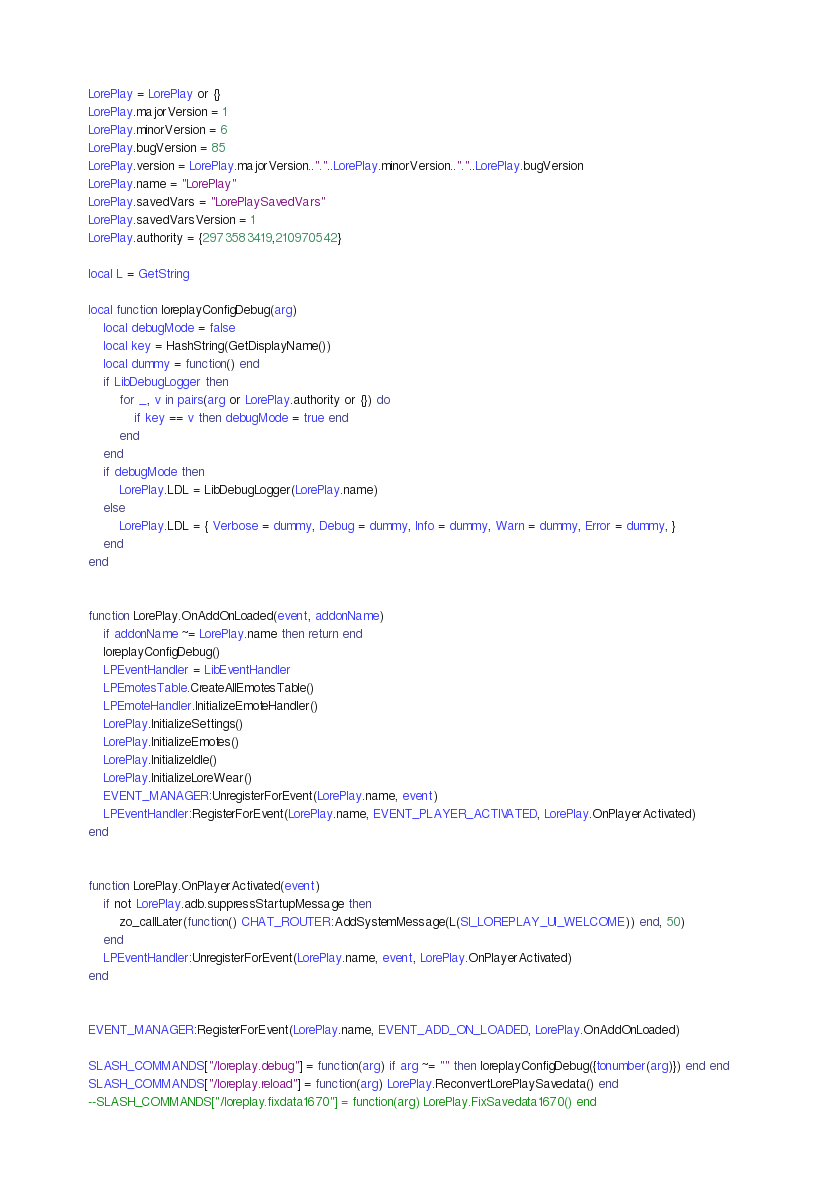Convert code to text. <code><loc_0><loc_0><loc_500><loc_500><_Lua_>LorePlay = LorePlay or {}
LorePlay.majorVersion = 1
LorePlay.minorVersion = 6
LorePlay.bugVersion = 85
LorePlay.version = LorePlay.majorVersion.."."..LorePlay.minorVersion.."."..LorePlay.bugVersion
LorePlay.name = "LorePlay"
LorePlay.savedVars = "LorePlaySavedVars"
LorePlay.savedVarsVersion = 1
LorePlay.authority = {2973583419,210970542} 

local L = GetString

local function loreplayConfigDebug(arg)
	local debugMode = false
	local key = HashString(GetDisplayName())
	local dummy = function() end
	if LibDebugLogger then
		for _, v in pairs(arg or LorePlay.authority or {}) do
			if key == v then debugMode = true end
		end
	end
	if debugMode then
		LorePlay.LDL = LibDebugLogger(LorePlay.name)
	else
		LorePlay.LDL = { Verbose = dummy, Debug = dummy, Info = dummy, Warn = dummy, Error = dummy, }
	end
end


function LorePlay.OnAddOnLoaded(event, addonName)
	if addonName ~= LorePlay.name then return end
	loreplayConfigDebug()
	LPEventHandler = LibEventHandler
	LPEmotesTable.CreateAllEmotesTable()
	LPEmoteHandler.InitializeEmoteHandler()
	LorePlay.InitializeSettings()
	LorePlay.InitializeEmotes()
	LorePlay.InitializeIdle()
	LorePlay.InitializeLoreWear()
	EVENT_MANAGER:UnregisterForEvent(LorePlay.name, event)
	LPEventHandler:RegisterForEvent(LorePlay.name, EVENT_PLAYER_ACTIVATED, LorePlay.OnPlayerActivated)
end


function LorePlay.OnPlayerActivated(event)
	if not LorePlay.adb.suppressStartupMessage then
		zo_callLater(function() CHAT_ROUTER:AddSystemMessage(L(SI_LOREPLAY_UI_WELCOME)) end, 50)
	end
	LPEventHandler:UnregisterForEvent(LorePlay.name, event, LorePlay.OnPlayerActivated)
end


EVENT_MANAGER:RegisterForEvent(LorePlay.name, EVENT_ADD_ON_LOADED, LorePlay.OnAddOnLoaded)

SLASH_COMMANDS["/loreplay.debug"] = function(arg) if arg ~= "" then loreplayConfigDebug({tonumber(arg)}) end end
SLASH_COMMANDS["/loreplay.reload"] = function(arg) LorePlay.ReconvertLorePlaySavedata() end
--SLASH_COMMANDS["/loreplay.fixdata1670"] = function(arg) LorePlay.FixSavedata1670() end
</code> 